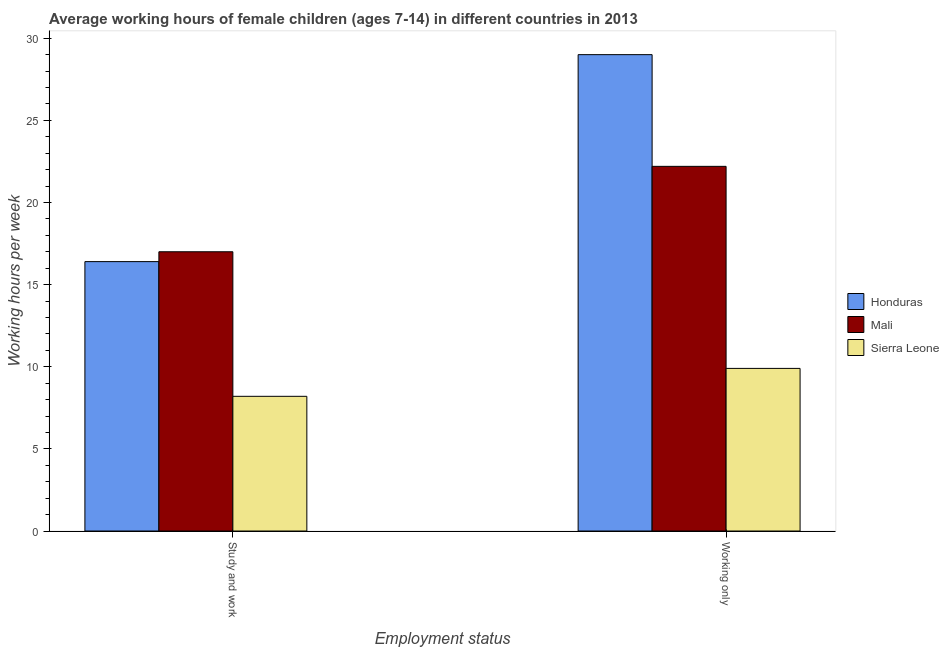How many groups of bars are there?
Make the answer very short. 2. Are the number of bars per tick equal to the number of legend labels?
Give a very brief answer. Yes. Are the number of bars on each tick of the X-axis equal?
Offer a terse response. Yes. What is the label of the 1st group of bars from the left?
Offer a very short reply. Study and work. Across all countries, what is the maximum average working hour of children involved in study and work?
Provide a short and direct response. 17. In which country was the average working hour of children involved in only work maximum?
Your answer should be compact. Honduras. In which country was the average working hour of children involved in study and work minimum?
Keep it short and to the point. Sierra Leone. What is the total average working hour of children involved in only work in the graph?
Offer a very short reply. 61.1. What is the difference between the average working hour of children involved in only work in Mali and that in Honduras?
Offer a terse response. -6.8. What is the average average working hour of children involved in only work per country?
Give a very brief answer. 20.37. What is the difference between the average working hour of children involved in study and work and average working hour of children involved in only work in Mali?
Your answer should be very brief. -5.2. What is the ratio of the average working hour of children involved in study and work in Mali to that in Honduras?
Give a very brief answer. 1.04. Is the average working hour of children involved in study and work in Mali less than that in Sierra Leone?
Your response must be concise. No. In how many countries, is the average working hour of children involved in only work greater than the average average working hour of children involved in only work taken over all countries?
Keep it short and to the point. 2. What does the 3rd bar from the left in Working only represents?
Your answer should be very brief. Sierra Leone. What does the 1st bar from the right in Study and work represents?
Offer a very short reply. Sierra Leone. How many bars are there?
Provide a short and direct response. 6. What is the difference between two consecutive major ticks on the Y-axis?
Keep it short and to the point. 5. Does the graph contain grids?
Offer a very short reply. No. Where does the legend appear in the graph?
Provide a short and direct response. Center right. How many legend labels are there?
Make the answer very short. 3. How are the legend labels stacked?
Ensure brevity in your answer.  Vertical. What is the title of the graph?
Offer a very short reply. Average working hours of female children (ages 7-14) in different countries in 2013. Does "Japan" appear as one of the legend labels in the graph?
Make the answer very short. No. What is the label or title of the X-axis?
Offer a terse response. Employment status. What is the label or title of the Y-axis?
Your answer should be compact. Working hours per week. What is the Working hours per week of Honduras in Study and work?
Provide a short and direct response. 16.4. What is the Working hours per week of Mali in Study and work?
Make the answer very short. 17. What is the Working hours per week of Honduras in Working only?
Offer a very short reply. 29. Across all Employment status, what is the maximum Working hours per week in Honduras?
Provide a short and direct response. 29. Across all Employment status, what is the maximum Working hours per week of Sierra Leone?
Provide a succinct answer. 9.9. Across all Employment status, what is the minimum Working hours per week in Sierra Leone?
Offer a terse response. 8.2. What is the total Working hours per week in Honduras in the graph?
Your response must be concise. 45.4. What is the total Working hours per week in Mali in the graph?
Give a very brief answer. 39.2. What is the difference between the Working hours per week in Honduras in Study and work and that in Working only?
Ensure brevity in your answer.  -12.6. What is the difference between the Working hours per week in Mali in Study and work and that in Working only?
Your answer should be compact. -5.2. What is the average Working hours per week in Honduras per Employment status?
Provide a short and direct response. 22.7. What is the average Working hours per week of Mali per Employment status?
Give a very brief answer. 19.6. What is the average Working hours per week of Sierra Leone per Employment status?
Offer a terse response. 9.05. What is the difference between the Working hours per week in Honduras and Working hours per week in Mali in Study and work?
Provide a short and direct response. -0.6. What is the difference between the Working hours per week in Honduras and Working hours per week in Sierra Leone in Study and work?
Keep it short and to the point. 8.2. What is the difference between the Working hours per week of Honduras and Working hours per week of Mali in Working only?
Offer a terse response. 6.8. What is the ratio of the Working hours per week in Honduras in Study and work to that in Working only?
Your answer should be very brief. 0.57. What is the ratio of the Working hours per week of Mali in Study and work to that in Working only?
Provide a short and direct response. 0.77. What is the ratio of the Working hours per week of Sierra Leone in Study and work to that in Working only?
Make the answer very short. 0.83. What is the difference between the highest and the second highest Working hours per week of Sierra Leone?
Your answer should be very brief. 1.7. What is the difference between the highest and the lowest Working hours per week in Mali?
Make the answer very short. 5.2. What is the difference between the highest and the lowest Working hours per week in Sierra Leone?
Your answer should be compact. 1.7. 